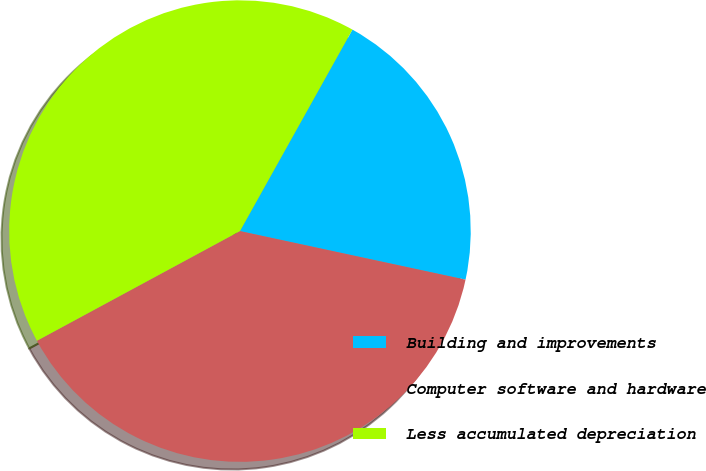<chart> <loc_0><loc_0><loc_500><loc_500><pie_chart><fcel>Building and improvements<fcel>Computer software and hardware<fcel>Less accumulated depreciation<nl><fcel>20.27%<fcel>38.74%<fcel>40.99%<nl></chart> 